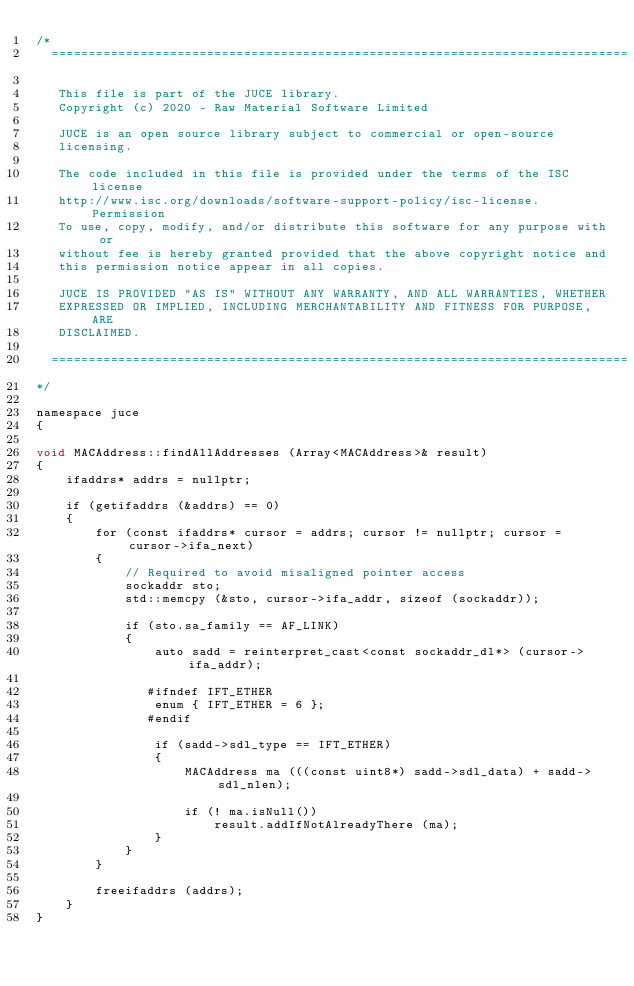Convert code to text. <code><loc_0><loc_0><loc_500><loc_500><_ObjectiveC_>/*
  ==============================================================================

   This file is part of the JUCE library.
   Copyright (c) 2020 - Raw Material Software Limited

   JUCE is an open source library subject to commercial or open-source
   licensing.

   The code included in this file is provided under the terms of the ISC license
   http://www.isc.org/downloads/software-support-policy/isc-license. Permission
   To use, copy, modify, and/or distribute this software for any purpose with or
   without fee is hereby granted provided that the above copyright notice and
   this permission notice appear in all copies.

   JUCE IS PROVIDED "AS IS" WITHOUT ANY WARRANTY, AND ALL WARRANTIES, WHETHER
   EXPRESSED OR IMPLIED, INCLUDING MERCHANTABILITY AND FITNESS FOR PURPOSE, ARE
   DISCLAIMED.

  ==============================================================================
*/

namespace juce
{

void MACAddress::findAllAddresses (Array<MACAddress>& result)
{
    ifaddrs* addrs = nullptr;

    if (getifaddrs (&addrs) == 0)
    {
        for (const ifaddrs* cursor = addrs; cursor != nullptr; cursor = cursor->ifa_next)
        {
            // Required to avoid misaligned pointer access
            sockaddr sto;
            std::memcpy (&sto, cursor->ifa_addr, sizeof (sockaddr));

            if (sto.sa_family == AF_LINK)
            {
                auto sadd = reinterpret_cast<const sockaddr_dl*> (cursor->ifa_addr);

               #ifndef IFT_ETHER
                enum { IFT_ETHER = 6 };
               #endif

                if (sadd->sdl_type == IFT_ETHER)
                {
                    MACAddress ma (((const uint8*) sadd->sdl_data) + sadd->sdl_nlen);

                    if (! ma.isNull())
                        result.addIfNotAlreadyThere (ma);
                }
            }
        }

        freeifaddrs (addrs);
    }
}
</code> 